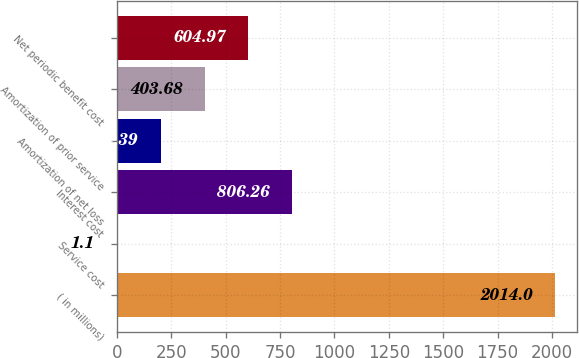Convert chart to OTSL. <chart><loc_0><loc_0><loc_500><loc_500><bar_chart><fcel>( in millions)<fcel>Service cost<fcel>Interest cost<fcel>Amortization of net loss<fcel>Amortization of prior service<fcel>Net periodic benefit cost<nl><fcel>2014<fcel>1.1<fcel>806.26<fcel>202.39<fcel>403.68<fcel>604.97<nl></chart> 